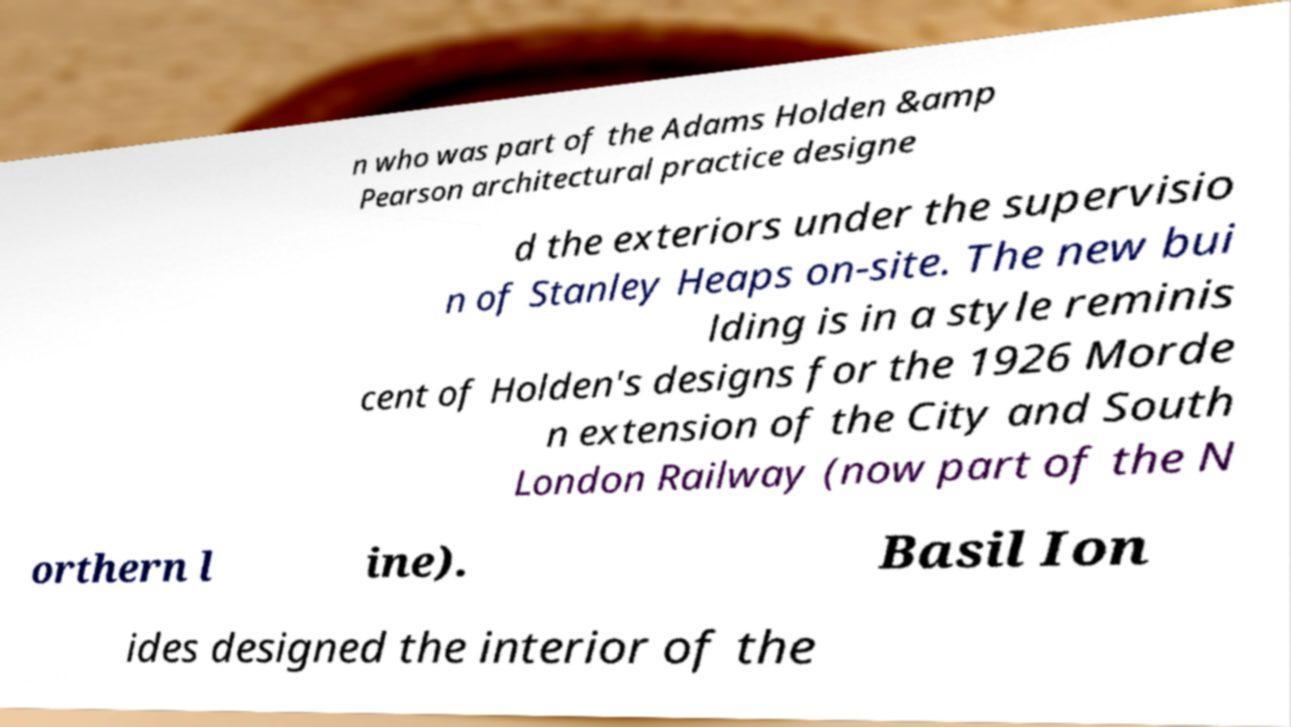Please identify and transcribe the text found in this image. n who was part of the Adams Holden &amp Pearson architectural practice designe d the exteriors under the supervisio n of Stanley Heaps on-site. The new bui lding is in a style reminis cent of Holden's designs for the 1926 Morde n extension of the City and South London Railway (now part of the N orthern l ine). Basil Ion ides designed the interior of the 